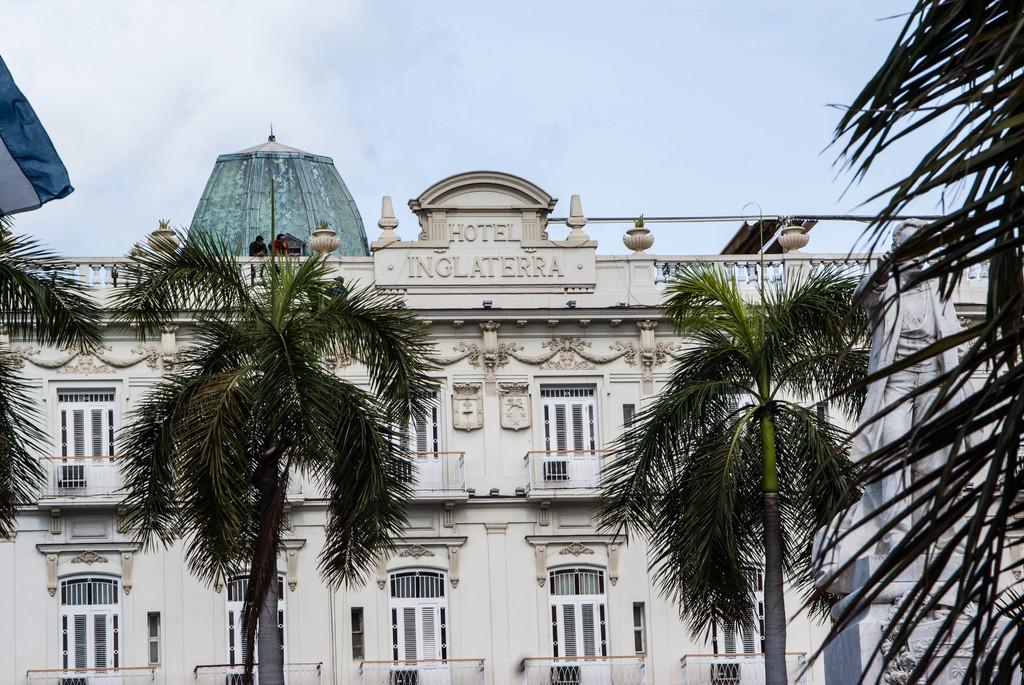What type of structure is visible in the image? There is a building in the image. What can be seen in front of the building? There are trees and a statue in front of the building. What is visible behind the building? The sky is visible behind the building. What type of pan is being used to cook food in the image? There is no pan or cooking activity present in the image. 